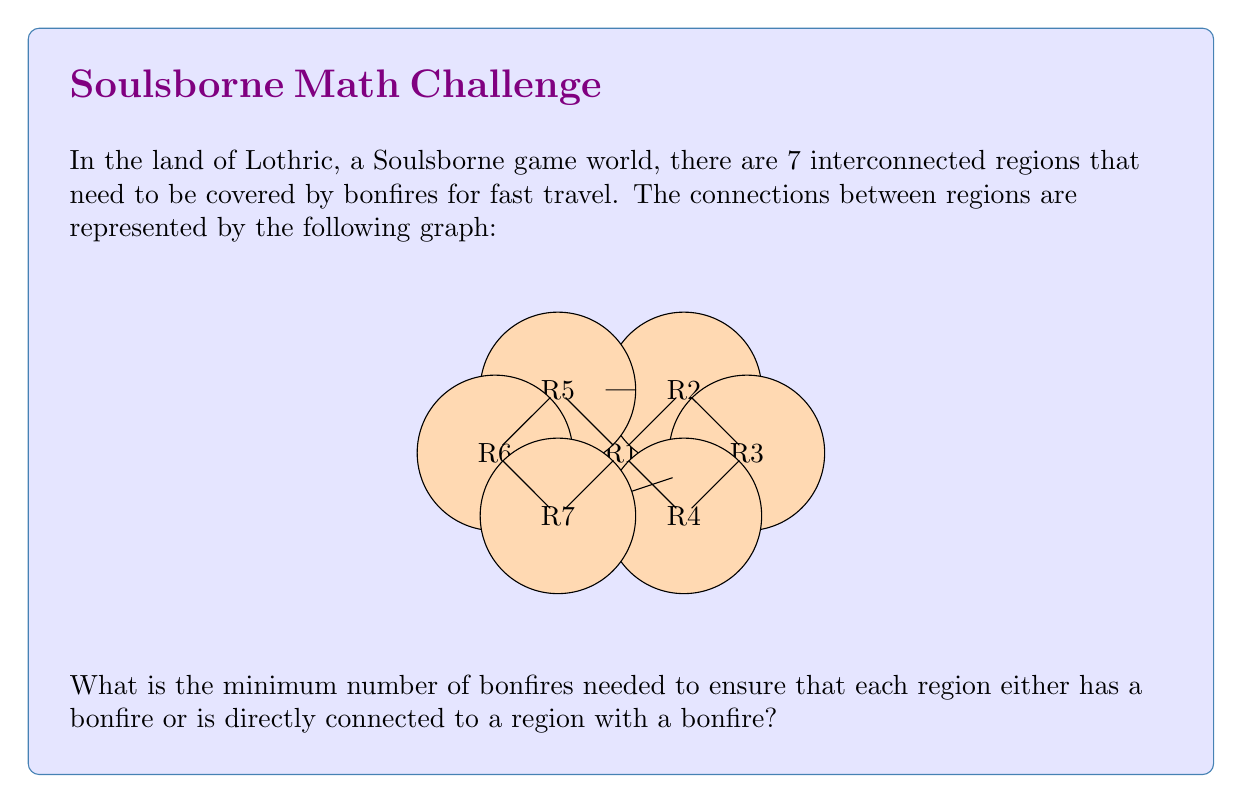Help me with this question. To solve this problem, we need to find the minimum dominating set of the given graph. A dominating set is a subset of vertices such that every vertex in the graph is either in the set or adjacent to a vertex in the set.

Let's approach this step-by-step:

1) First, observe that the graph has a symmetrical structure with two cycles connected by two edges.

2) We can cover most of the graph efficiently by placing bonfires at the vertices that connect the two cycles. These are R1 and R3.

3) Placing bonfires at R1 and R3 covers:
   - R1, R2, R3, R4 (from R1)
   - R1, R2, R3, R7 (from R3)

4) However, this leaves R5 and R6 uncovered.

5) To cover R5 and R6, we need one more bonfire. We can place it at either R5 or R6.

6) Let's choose R5. Now our bonfire placement covers all regions:
   - R1 covers R1, R2, R4, R5
   - R3 covers R3, R7
   - R5 covers R5, R6

Therefore, the minimum number of bonfires needed is 3.

This solution is optimal because:
- We need at least one bonfire to cover the left cycle (R4, R5, R6, R7)
- We need at least one bonfire to cover the right cycle (R1, R2, R3, R4)
- These two bonfires cannot cover all vertices, so we need at least one more

Thus, 3 is the minimum possible number of bonfires.
Answer: 3 bonfires 